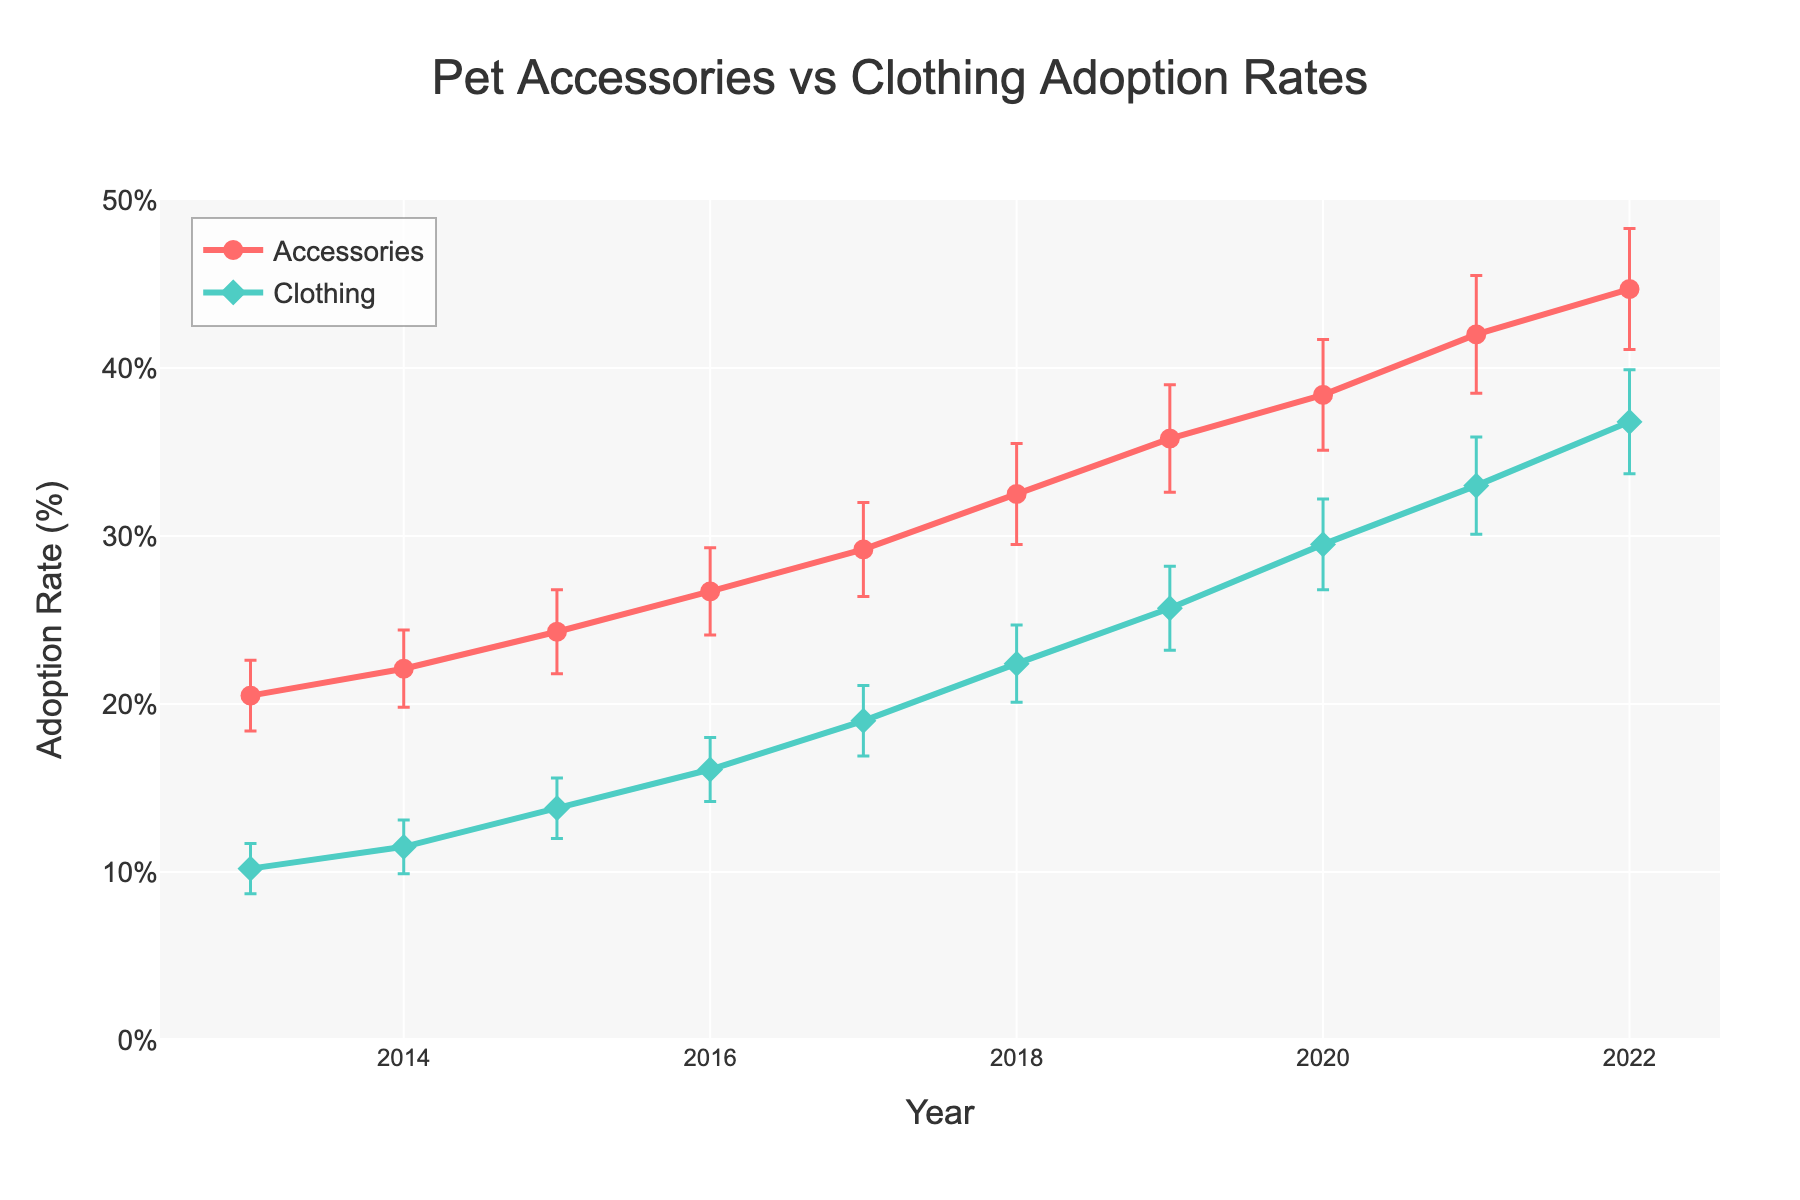what is the title of the plot? The title of the plot is typically written at the top center of the figure. In this case, the title is "Pet Accessories vs Clothing Adoption Rates".
Answer: Pet Accessories vs Clothing Adoption Rates which category has higher adoption rates in 2020? The adoption rates in 2020 for both categories are shown in the plot as points along the respective lines. By comparing the y-values of the two lines at the 2020 mark on the x-axis, it's clear that the adoption rate for Accessories is higher than that of Clothing.
Answer: Accessories what is the adoption rate of accessories in 2015? The adoption rate for Accessories in 2015 can be found by locating the corresponding point on the Accessories line when x equals 2015. The y-value of this point indicates the adoption rate, which is 24.3%.
Answer: 24.3% how much did the adoption rate of clothing increase from 2017 to 2022? To find the increase, subtract the adoption rate of Clothing in 2017 from that in 2022. From the plot, these rates are approximately 19.0% and 36.8%, respectively. 36.8% - 19.0% = 17.8%.
Answer: 17.8% which year shows the largest difference in adoption rates between accessories and clothing? The difference in adoption rates for each year can be found by subtracting the Clothing rate from the Accessories rate. The year with the largest difference will have the highest resulting value. By inspecting the graph, 2022 has the largest difference, calculated as 44.7% - 36.8% = 7.9%.
Answer: 2022 what is the range of the adoption rate axis? The range of the y-axis, showing adoption rates, can be observed from the y-axis labels. The plot ranges from 0% to 50%.
Answer: 0% to 50% are the confidence intervals for clothing adoption rates consistent over the decade? By examining the error bars for the Clothing adoption rates from 2013 to 2022, it's clear that the length of the error bars changes gradually. This indicates that the confidence intervals slightly increase over time but remain relatively consistent in pattern.
Answer: Approximately consistent what is the overall trend in adoption rates of both accessories and clothing? The general direction of both lines can be observed starting from the left (2013) to the right (2022). Both lines trend upward, indicating increasing adoption rates for both categories over the decade.
Answer: Increasing in which year do the adoption rates of accessories exceed 30%? The point where the Accessories line first crosses above the 30% mark on the y-axis can be observed as corresponding to the year 2018.
Answer: 2018 how does the confidence interval of accessories in 2015 compare to that of clothing in the same year? The plot shows error bars representing confidence intervals. For 2015, the error bar for Accessories is 2.5% and for Clothing, it is 1.8%. The confidence interval for Accessories is wider.
Answer: Accessories have a wider interval 